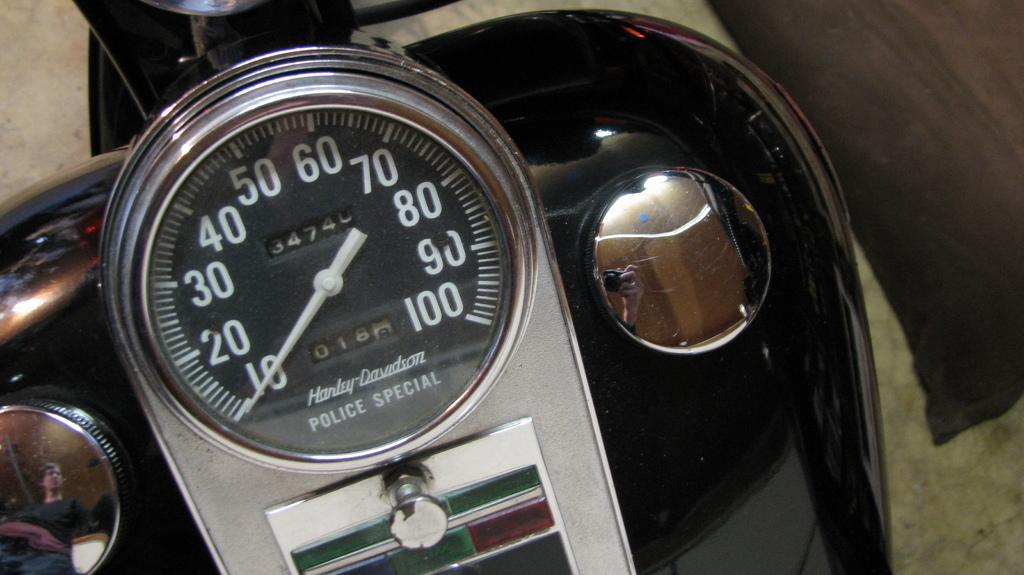What is the main subject in the center of the image? There is a speedometer in the center of the image. What is the speedometer attached to? The speedometer is on a vehicle. How does the speedometer shake in the image? The speedometer does not shake in the image; it is stationary on the vehicle. Is the vehicle in the image sleeping? The concept of a vehicle sleeping is not applicable, as vehicles do not have the ability to sleep. 